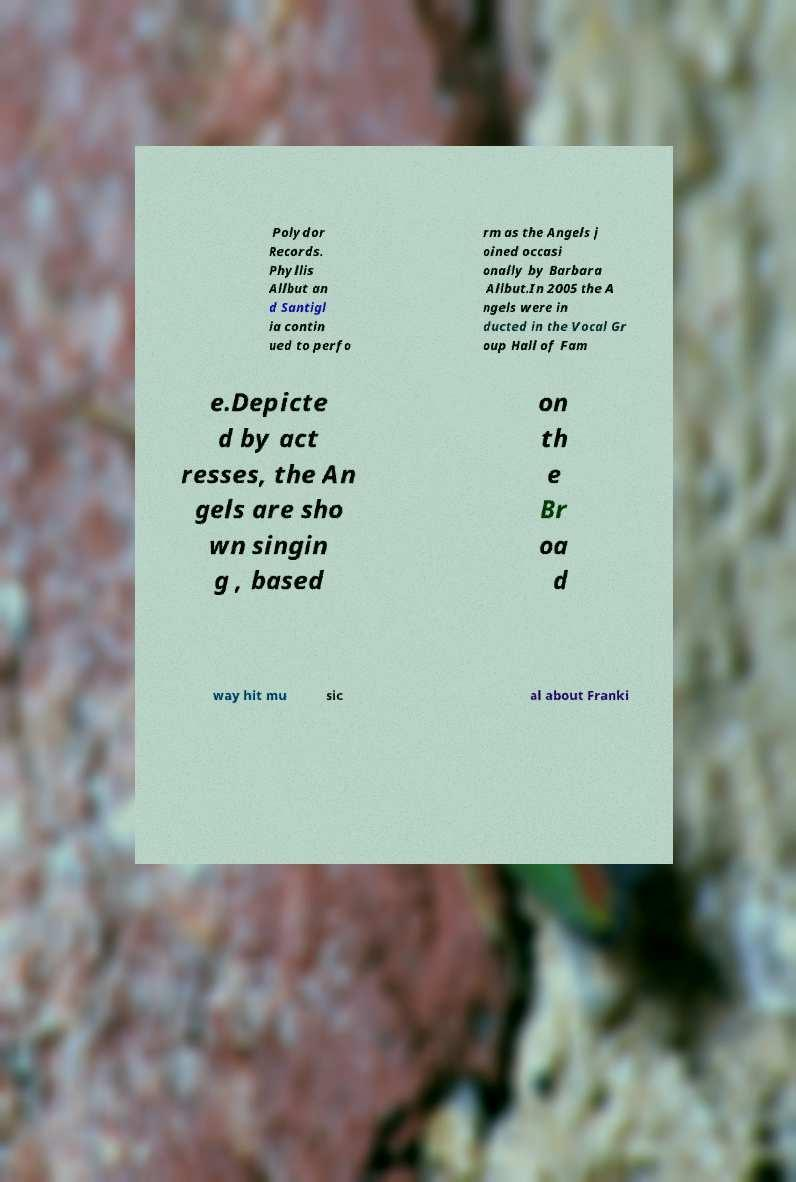For documentation purposes, I need the text within this image transcribed. Could you provide that? Polydor Records. Phyllis Allbut an d Santigl ia contin ued to perfo rm as the Angels j oined occasi onally by Barbara Allbut.In 2005 the A ngels were in ducted in the Vocal Gr oup Hall of Fam e.Depicte d by act resses, the An gels are sho wn singin g , based on th e Br oa d way hit mu sic al about Franki 